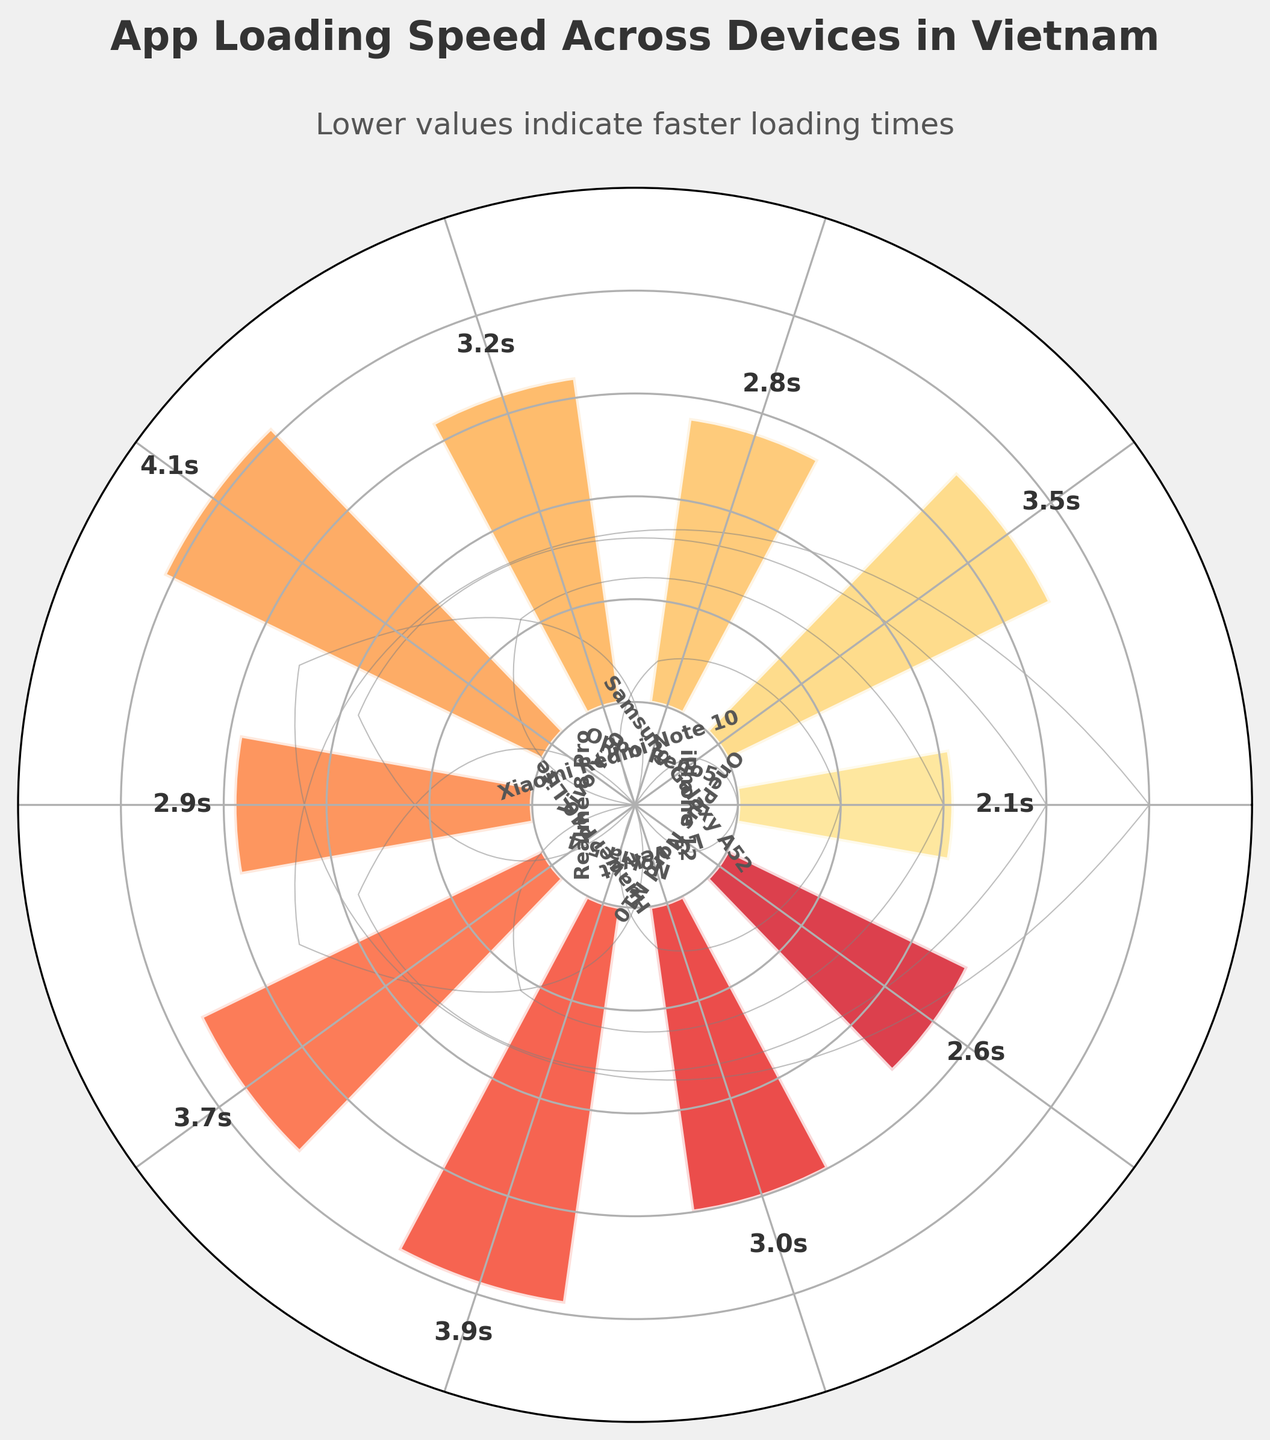What's the title of the gauge chart? The title is usually located at the top of the chart. In this chart, it reads "App Loading Speed Across Devices in Vietnam".
Answer: App Loading Speed Across Devices in Vietnam How are the devices labeled on the chart? The device labels are placed near the center, around the base of each gauge. They indicate the different mobile devices, such as iPhone 12, Samsung Galaxy A52, etc.
Answer: Near the center Which device has the fastest loading speed? To find the fastest loading speed, look for the shortest bar, as the loading speed is measured in seconds. The iPhone 12 has the shortest bar with a loading speed of 2.1 seconds.
Answer: iPhone 12 Which device has the slowest loading speed? To determine the device with the slowest loading speed, look for the tallest bar. The Vivo Y20 has the tallest bar with a loading speed of 4.1 seconds.
Answer: Vivo Y20 What's the difference in loading speed between the fastest and slowest devices? The fastest device is the iPhone 12 with 2.1 seconds, and the slowest is the Vivo Y20 with 4.1 seconds. The difference is 4.1 - 2.1.
Answer: 2.0 seconds What is the average loading speed of all devices? To find this, sum all the loading speeds (2.1 + 3.5 + 2.8 + 3.2 + 4.1 + 2.9 + 3.7 + 3.9 + 3.0 + 2.6) and divide by the number of devices (10). The total is 31.8, so 31.8 / 10.
Answer: 3.18 seconds How many devices have a loading speed less than 3 seconds? Count the number of bars with a length less than 3. The devices are iPhone 12 (2.1), Oppo Reno5 (2.8), Realme 8 Pro (2.9), and OnePlus Nord N10 (2.6).
Answer: 4 devices Which device has a loading speed close to the average loading speed of 3.18 seconds? Look for the device with a value closest to 3.18. The Xiaomi Redmi Note 10 has a loading speed of 3.2 seconds, which is closest to 3.18.
Answer: Xiaomi Redmi Note 10 How is the loading speed of Samsung Galaxy A52 compared to Xiaomi Redmi Note 10? Samsung Galaxy A52 has a loading speed of 3.5 seconds, while Xiaomi Redmi Note 10 has 3.2 seconds. Compare 3.5 to 3.2.
Answer: Samsung Galaxy A52 is slower 